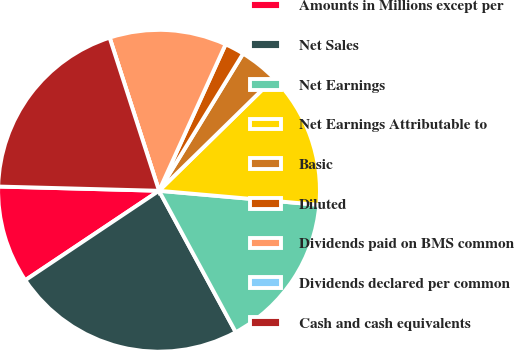Convert chart. <chart><loc_0><loc_0><loc_500><loc_500><pie_chart><fcel>Amounts in Millions except per<fcel>Net Sales<fcel>Net Earnings<fcel>Net Earnings Attributable to<fcel>Basic<fcel>Diluted<fcel>Dividends paid on BMS common<fcel>Dividends declared per common<fcel>Cash and cash equivalents<nl><fcel>9.8%<fcel>23.53%<fcel>15.69%<fcel>13.73%<fcel>3.92%<fcel>1.96%<fcel>11.76%<fcel>0.0%<fcel>19.61%<nl></chart> 